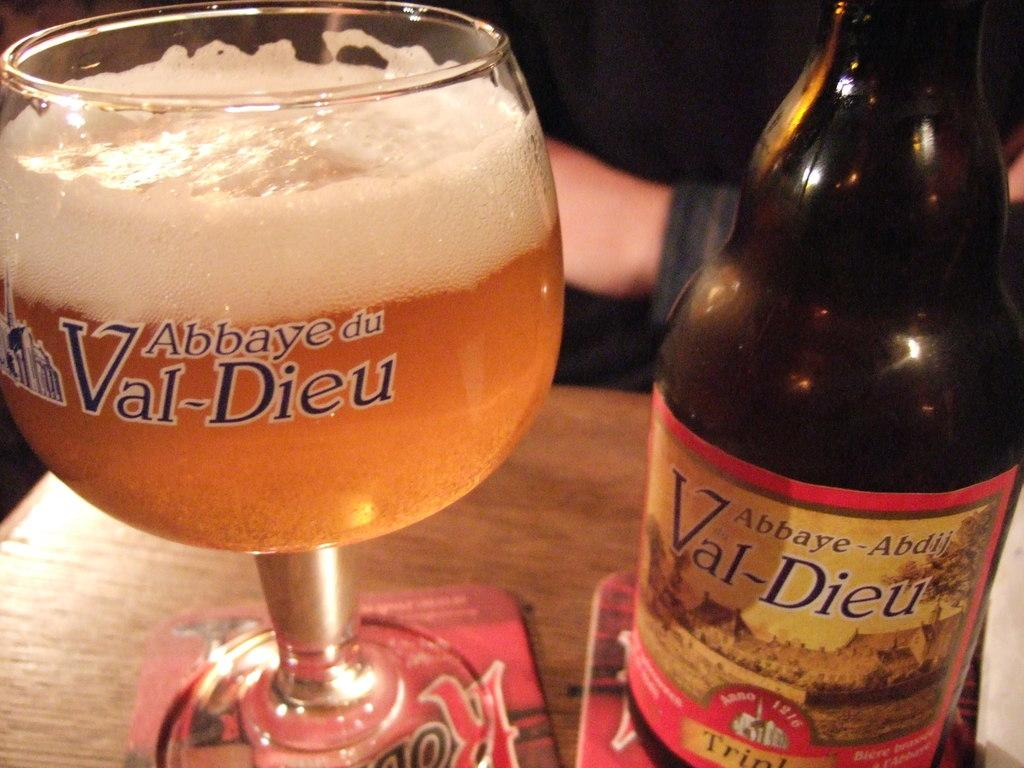What is the main object in the image? There is a wine bottle in the image. What is the wine bottle placed next to? There is a glass filled with a drink in the image, and the wine bottle and glass are placed on a table. What color is the table cover? The table has a red-colored table cover. How many thumbs can be seen in the image? There are no thumbs mentioned or depicted in the image. What type of camera is being used to take the picture? The text does not mention any camera being used to take the picture. 